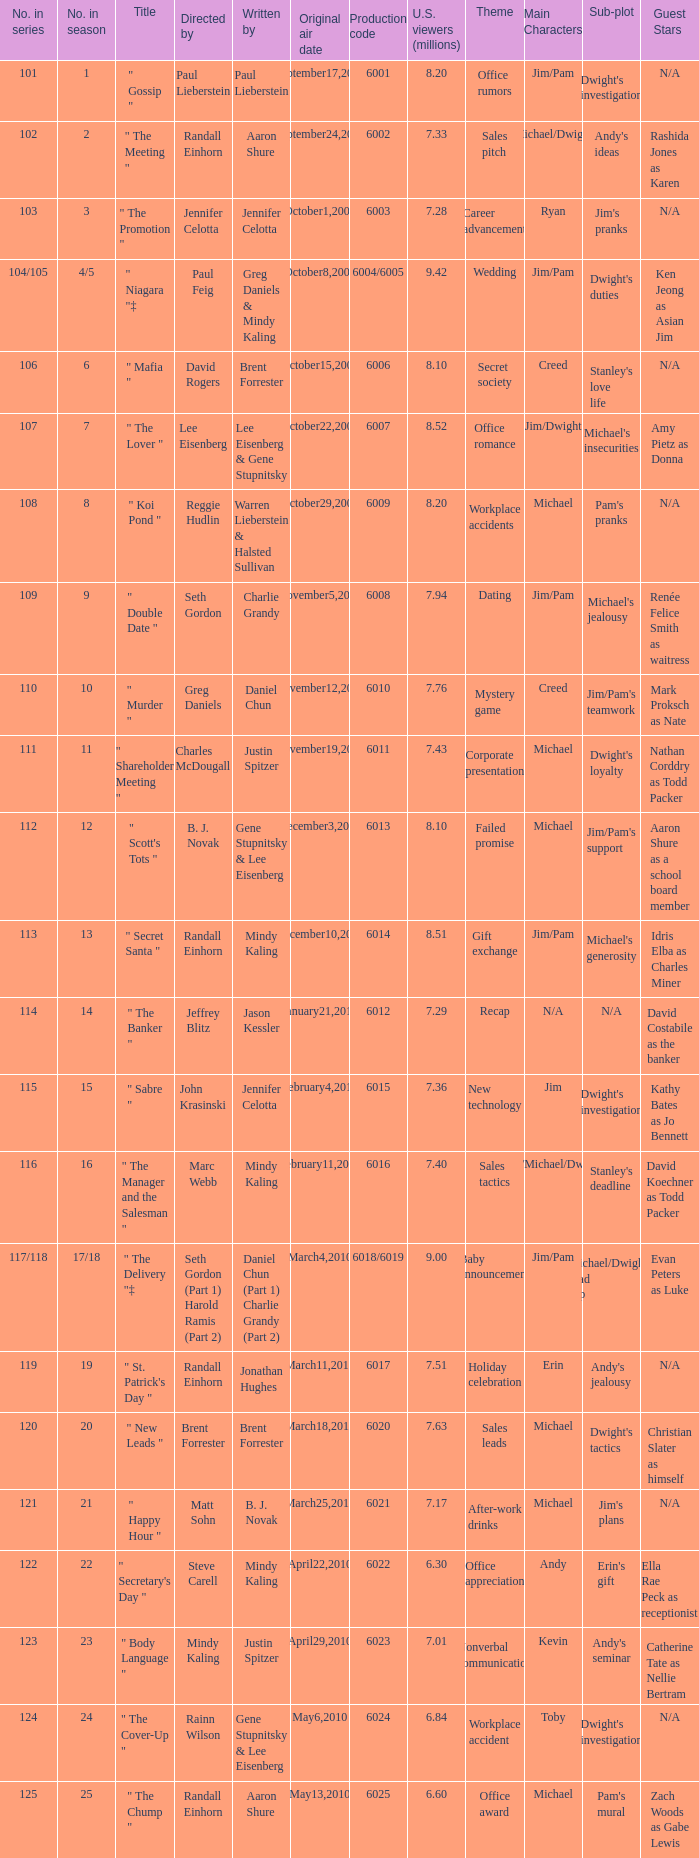Name the production code for number in season being 21 6021.0. 